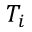<formula> <loc_0><loc_0><loc_500><loc_500>T _ { i }</formula> 